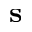<formula> <loc_0><loc_0><loc_500><loc_500>s</formula> 